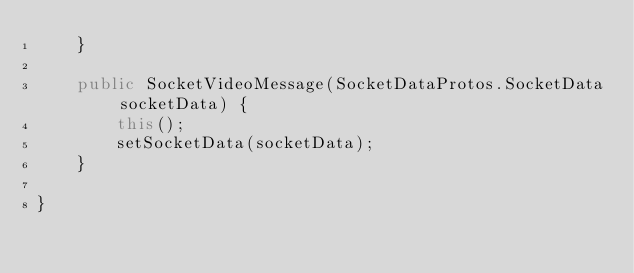Convert code to text. <code><loc_0><loc_0><loc_500><loc_500><_Java_>    }

    public SocketVideoMessage(SocketDataProtos.SocketData socketData) {
        this();
        setSocketData(socketData);
    }

}
</code> 